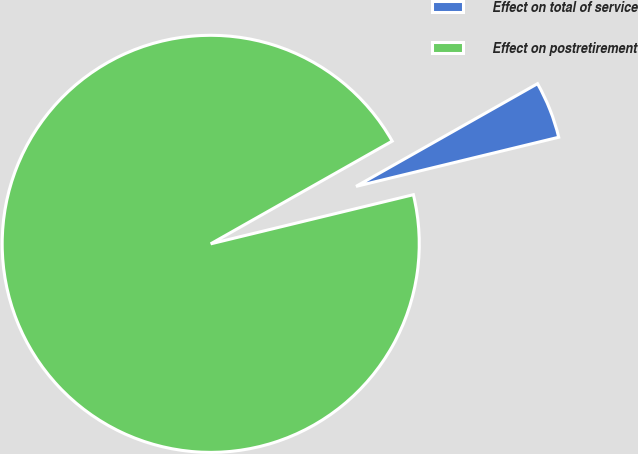<chart> <loc_0><loc_0><loc_500><loc_500><pie_chart><fcel>Effect on total of service<fcel>Effect on postretirement<nl><fcel>4.41%<fcel>95.59%<nl></chart> 